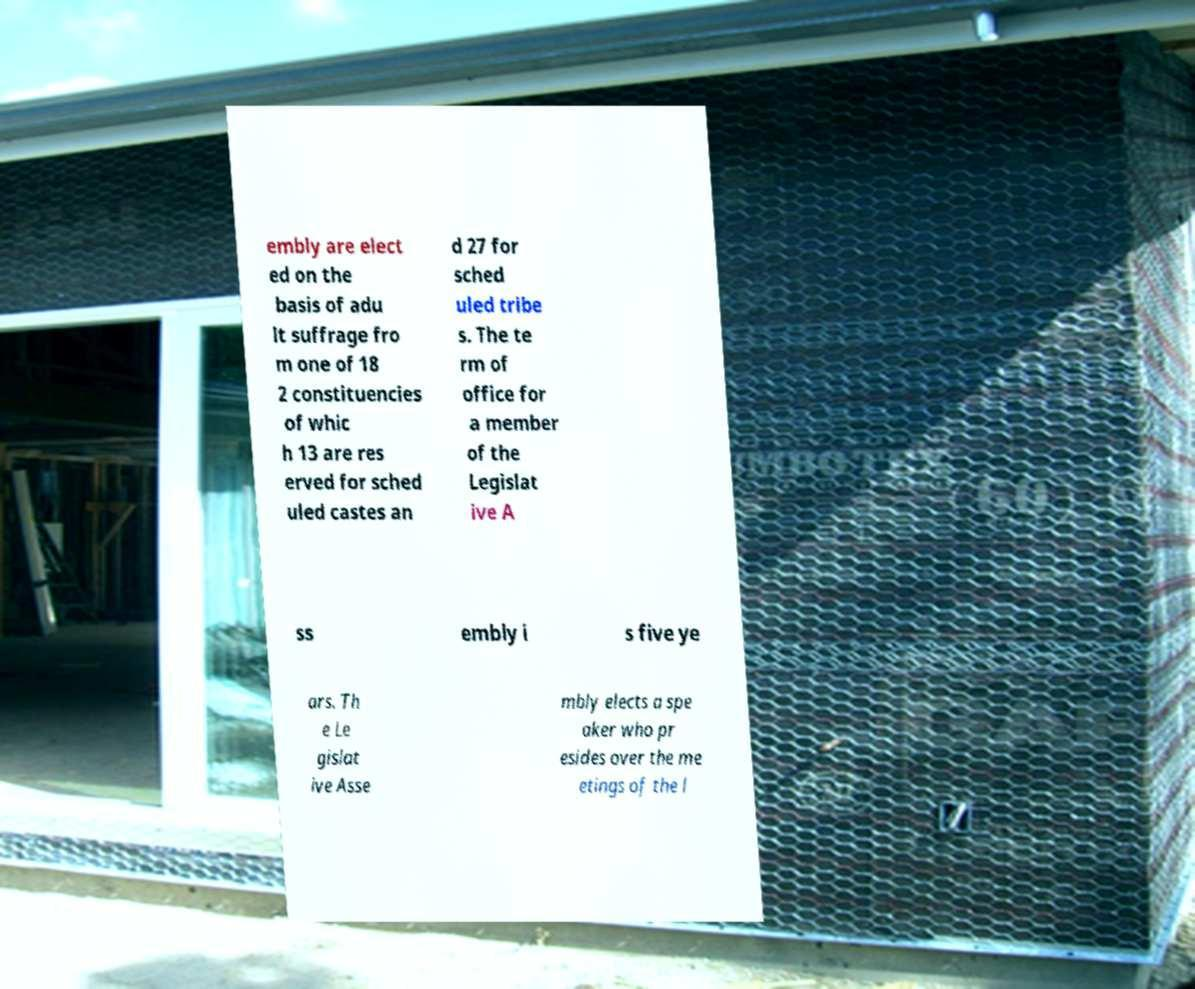Could you assist in decoding the text presented in this image and type it out clearly? embly are elect ed on the basis of adu lt suffrage fro m one of 18 2 constituencies of whic h 13 are res erved for sched uled castes an d 27 for sched uled tribe s. The te rm of office for a member of the Legislat ive A ss embly i s five ye ars. Th e Le gislat ive Asse mbly elects a spe aker who pr esides over the me etings of the l 